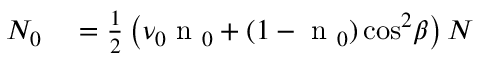Convert formula to latex. <formula><loc_0><loc_0><loc_500><loc_500>\begin{array} { r l } { N _ { 0 } } & = \frac { 1 } { 2 } \left ( \nu _ { 0 } n _ { 0 } + ( 1 - n _ { 0 } ) \cos ^ { 2 } \, \beta \right ) N } \end{array}</formula> 